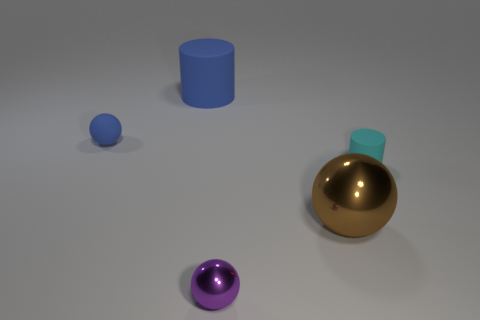Add 4 brown objects. How many objects exist? 9 Subtract all cylinders. How many objects are left? 3 Subtract 0 yellow spheres. How many objects are left? 5 Subtract all brown metallic spheres. Subtract all small purple metallic spheres. How many objects are left? 3 Add 3 large brown metal objects. How many large brown metal objects are left? 4 Add 4 purple spheres. How many purple spheres exist? 5 